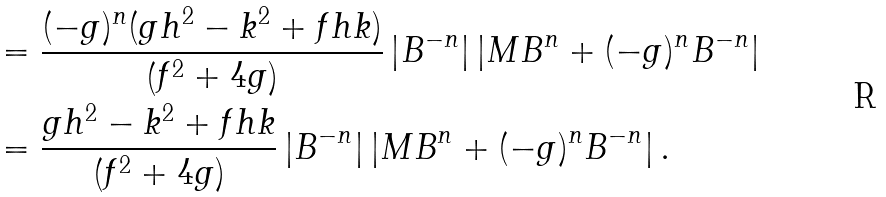Convert formula to latex. <formula><loc_0><loc_0><loc_500><loc_500>& = \frac { ( - g ) ^ { n } ( g h ^ { 2 } - k ^ { 2 } + f h k ) } { \left ( f ^ { 2 } + 4 g \right ) } \left | B ^ { - n } \right | \left | M B ^ { n } + ( - g ) ^ { n } B ^ { - n } \right | \\ & = \frac { g h ^ { 2 } - k ^ { 2 } + f h k } { \left ( f ^ { 2 } + 4 g \right ) } \left | B ^ { - n } \right | \left | M B ^ { n } + ( - g ) ^ { n } B ^ { - n } \right | .</formula> 